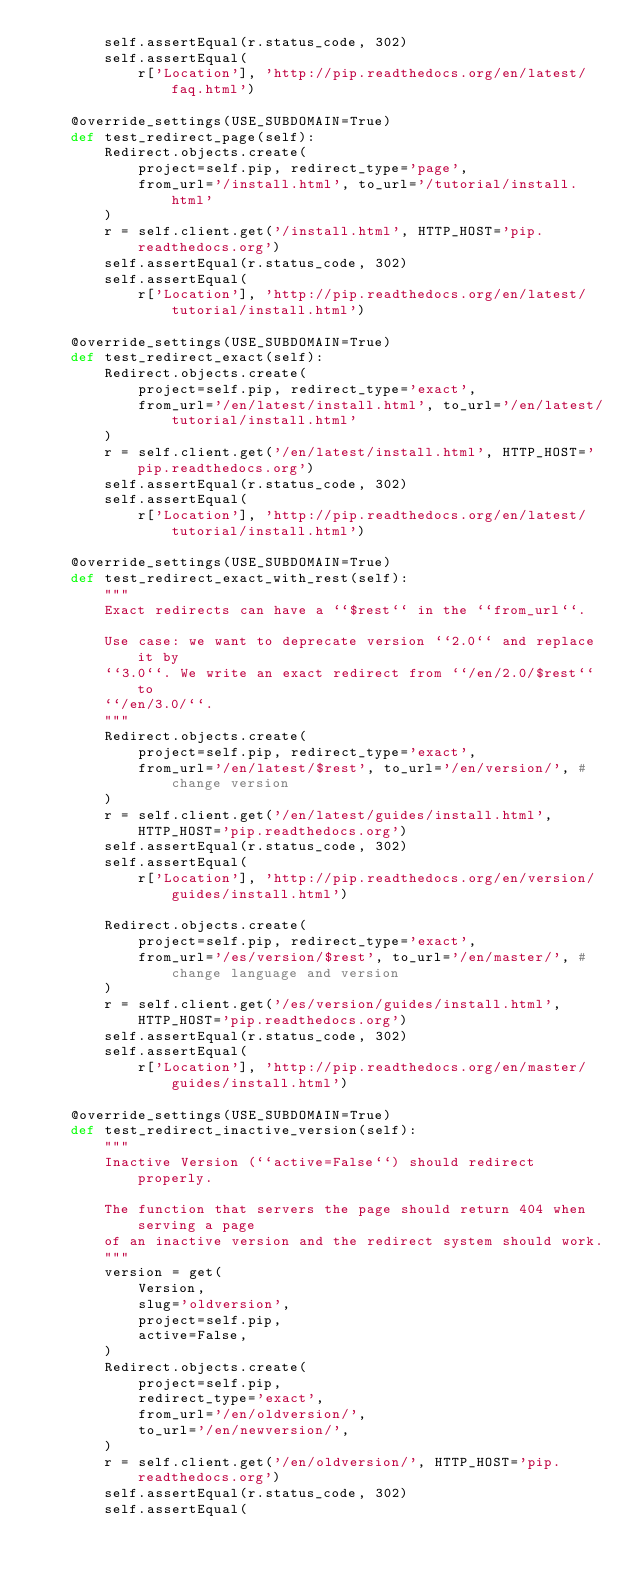<code> <loc_0><loc_0><loc_500><loc_500><_Python_>        self.assertEqual(r.status_code, 302)
        self.assertEqual(
            r['Location'], 'http://pip.readthedocs.org/en/latest/faq.html')

    @override_settings(USE_SUBDOMAIN=True)
    def test_redirect_page(self):
        Redirect.objects.create(
            project=self.pip, redirect_type='page',
            from_url='/install.html', to_url='/tutorial/install.html'
        )
        r = self.client.get('/install.html', HTTP_HOST='pip.readthedocs.org')
        self.assertEqual(r.status_code, 302)
        self.assertEqual(
            r['Location'], 'http://pip.readthedocs.org/en/latest/tutorial/install.html')

    @override_settings(USE_SUBDOMAIN=True)
    def test_redirect_exact(self):
        Redirect.objects.create(
            project=self.pip, redirect_type='exact',
            from_url='/en/latest/install.html', to_url='/en/latest/tutorial/install.html'
        )
        r = self.client.get('/en/latest/install.html', HTTP_HOST='pip.readthedocs.org')
        self.assertEqual(r.status_code, 302)
        self.assertEqual(
            r['Location'], 'http://pip.readthedocs.org/en/latest/tutorial/install.html')

    @override_settings(USE_SUBDOMAIN=True)
    def test_redirect_exact_with_rest(self):
        """
        Exact redirects can have a ``$rest`` in the ``from_url``.

        Use case: we want to deprecate version ``2.0`` and replace it by
        ``3.0``. We write an exact redirect from ``/en/2.0/$rest`` to
        ``/en/3.0/``.
        """
        Redirect.objects.create(
            project=self.pip, redirect_type='exact',
            from_url='/en/latest/$rest', to_url='/en/version/', # change version
        )
        r = self.client.get('/en/latest/guides/install.html', HTTP_HOST='pip.readthedocs.org')
        self.assertEqual(r.status_code, 302)
        self.assertEqual(
            r['Location'], 'http://pip.readthedocs.org/en/version/guides/install.html')

        Redirect.objects.create(
            project=self.pip, redirect_type='exact',
            from_url='/es/version/$rest', to_url='/en/master/', # change language and version
        )
        r = self.client.get('/es/version/guides/install.html', HTTP_HOST='pip.readthedocs.org')
        self.assertEqual(r.status_code, 302)
        self.assertEqual(
            r['Location'], 'http://pip.readthedocs.org/en/master/guides/install.html')

    @override_settings(USE_SUBDOMAIN=True)
    def test_redirect_inactive_version(self):
        """
        Inactive Version (``active=False``) should redirect properly.

        The function that servers the page should return 404 when serving a page
        of an inactive version and the redirect system should work.
        """
        version = get(
            Version,
            slug='oldversion',
            project=self.pip,
            active=False,
        )
        Redirect.objects.create(
            project=self.pip,
            redirect_type='exact',
            from_url='/en/oldversion/',
            to_url='/en/newversion/',
        )
        r = self.client.get('/en/oldversion/', HTTP_HOST='pip.readthedocs.org')
        self.assertEqual(r.status_code, 302)
        self.assertEqual(</code> 